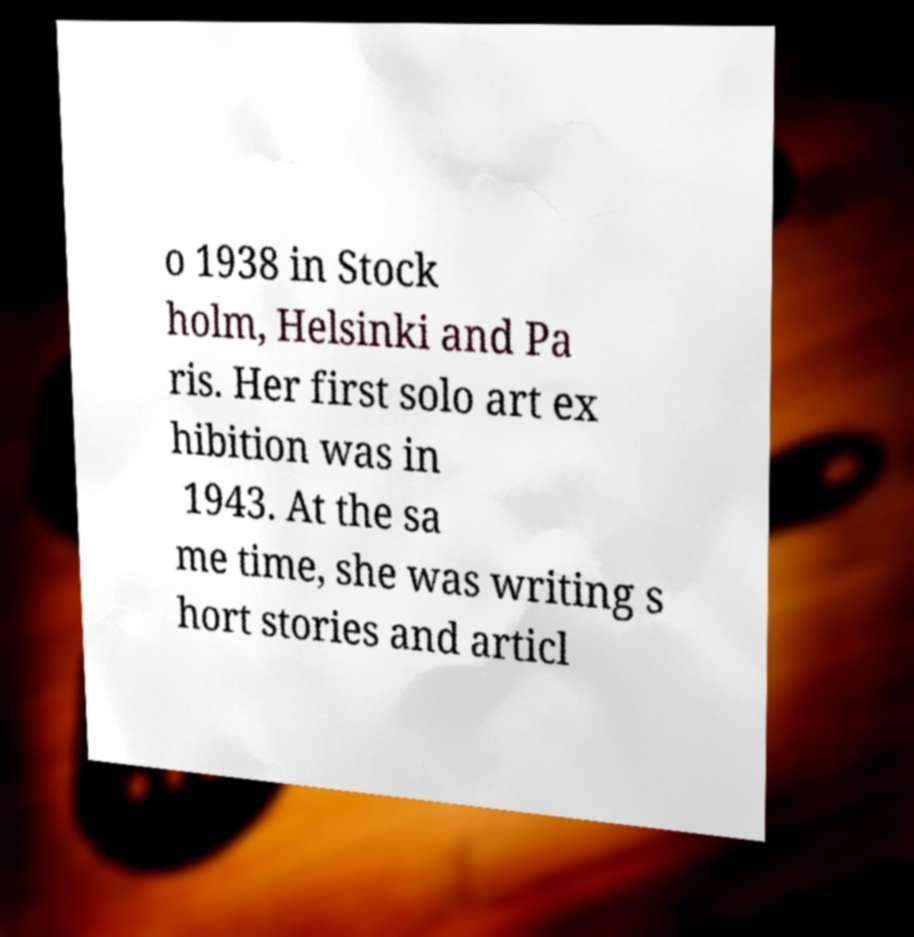Please identify and transcribe the text found in this image. o 1938 in Stock holm, Helsinki and Pa ris. Her first solo art ex hibition was in 1943. At the sa me time, she was writing s hort stories and articl 